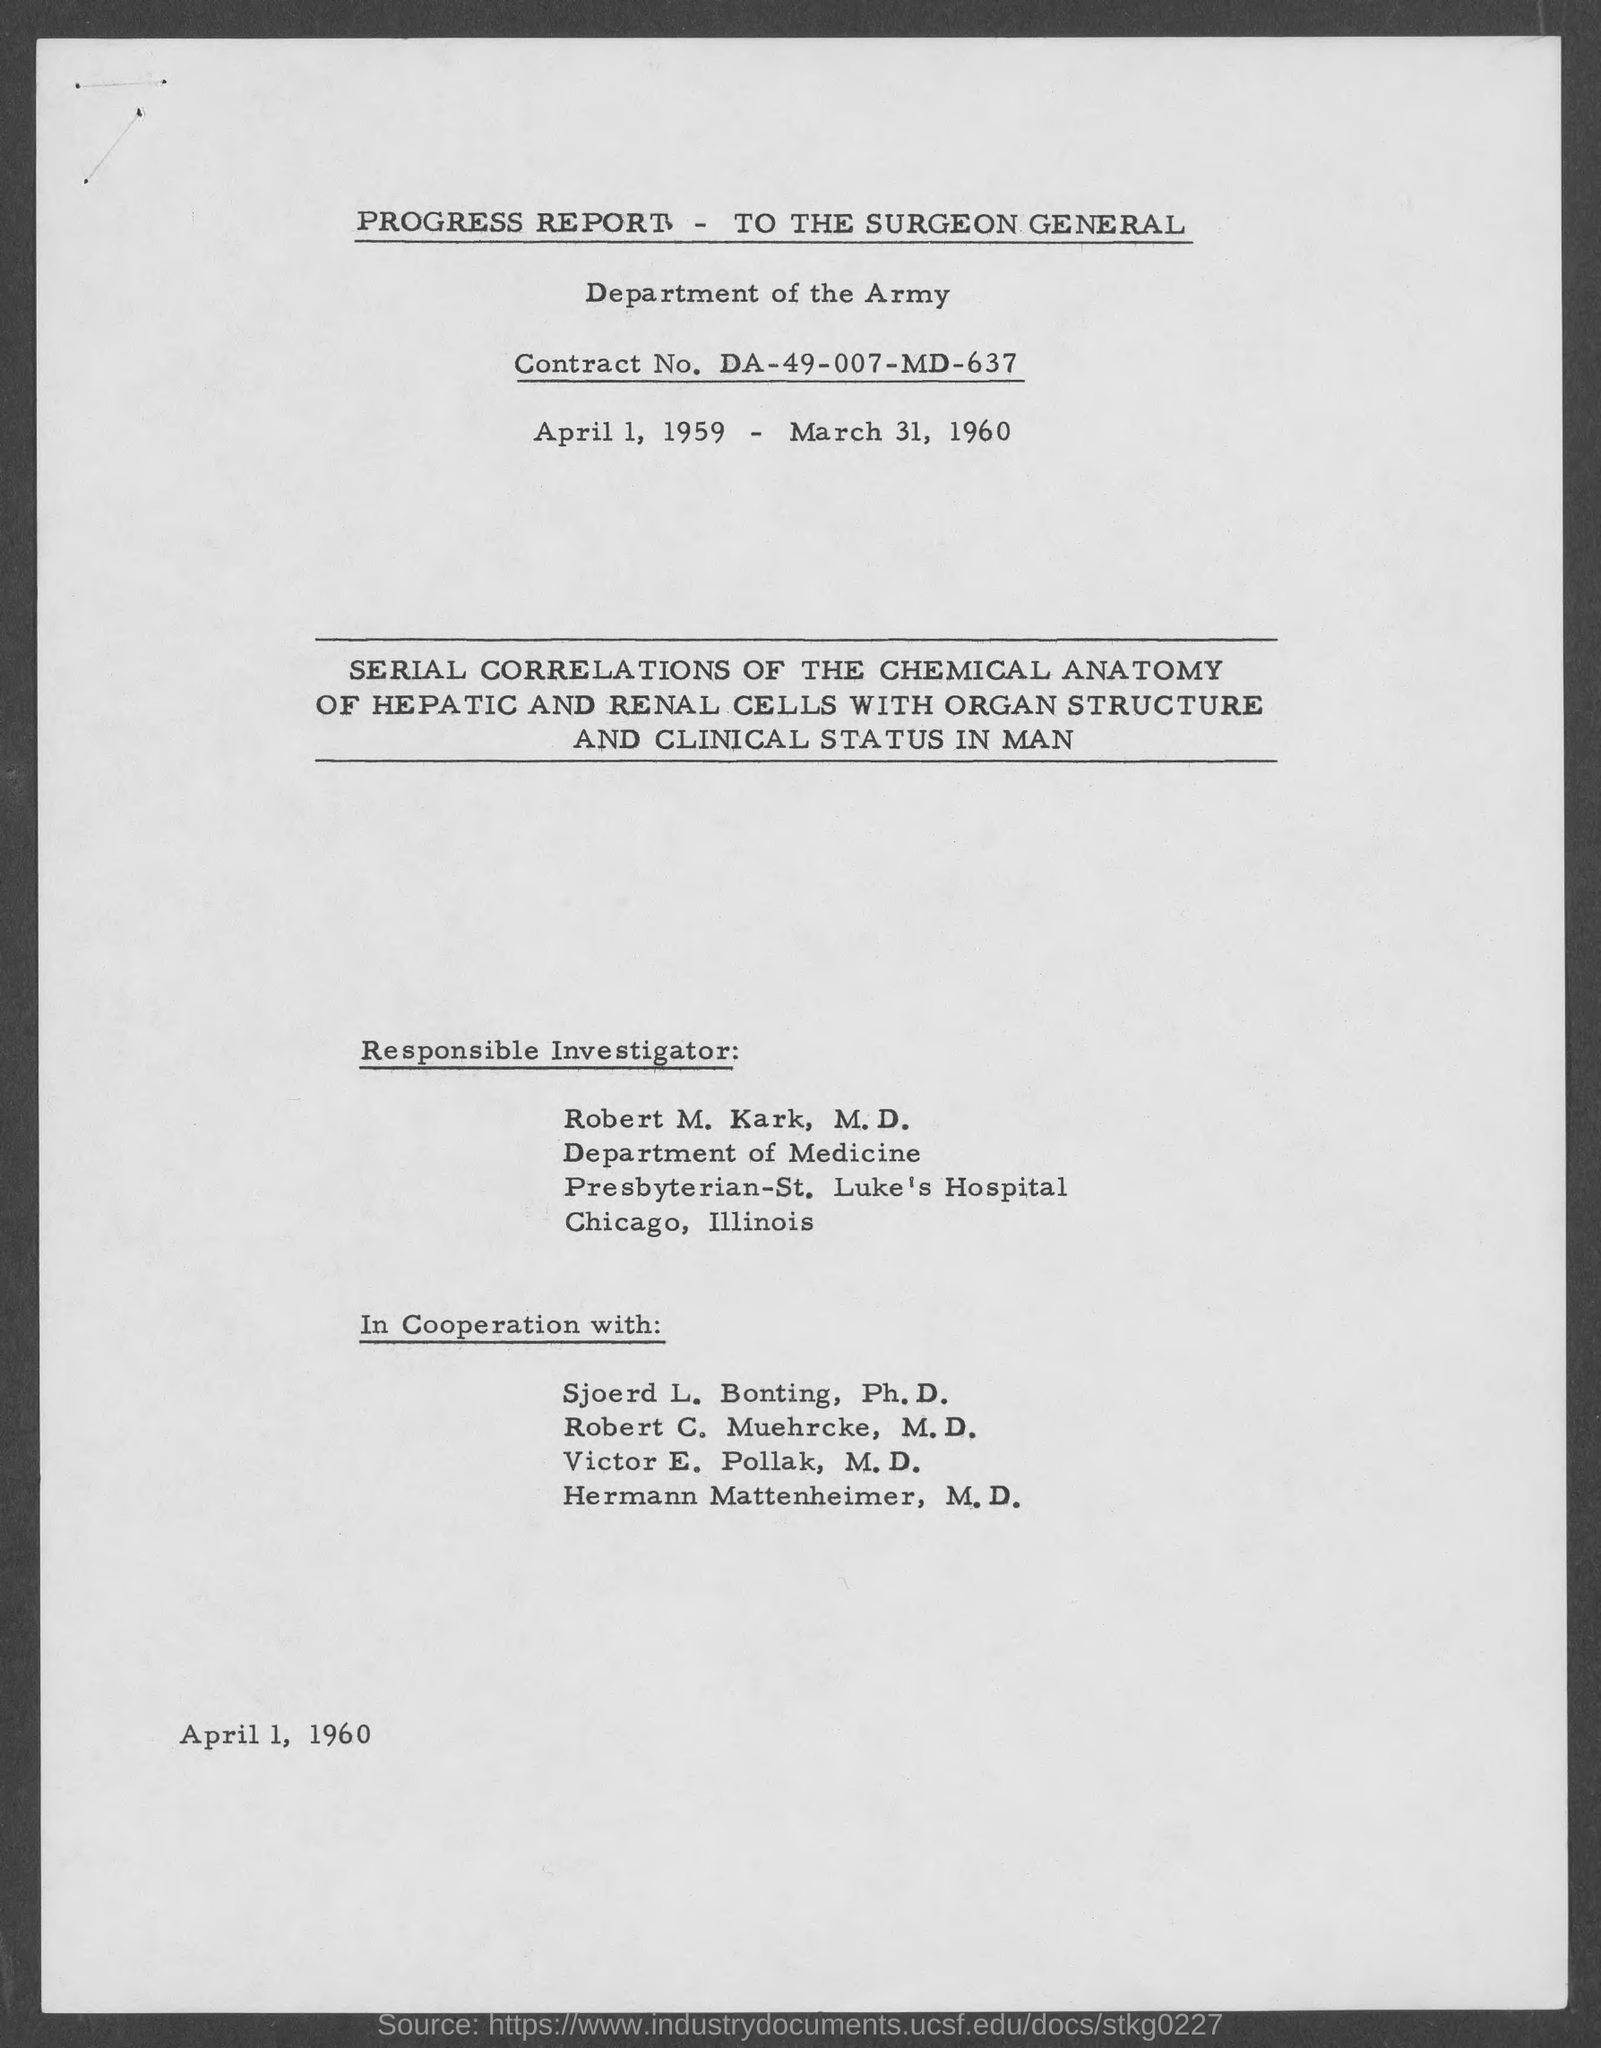Point out several critical features in this image. The responsible investigator is Robert M. Kark, M.D. Robert M. Kark belongs to the Department of Medicine. The date at the bottom of the page is April 1, 1960. What is the contract number? DA-49-007-MD-637..." is a question asking for information about a contract. 